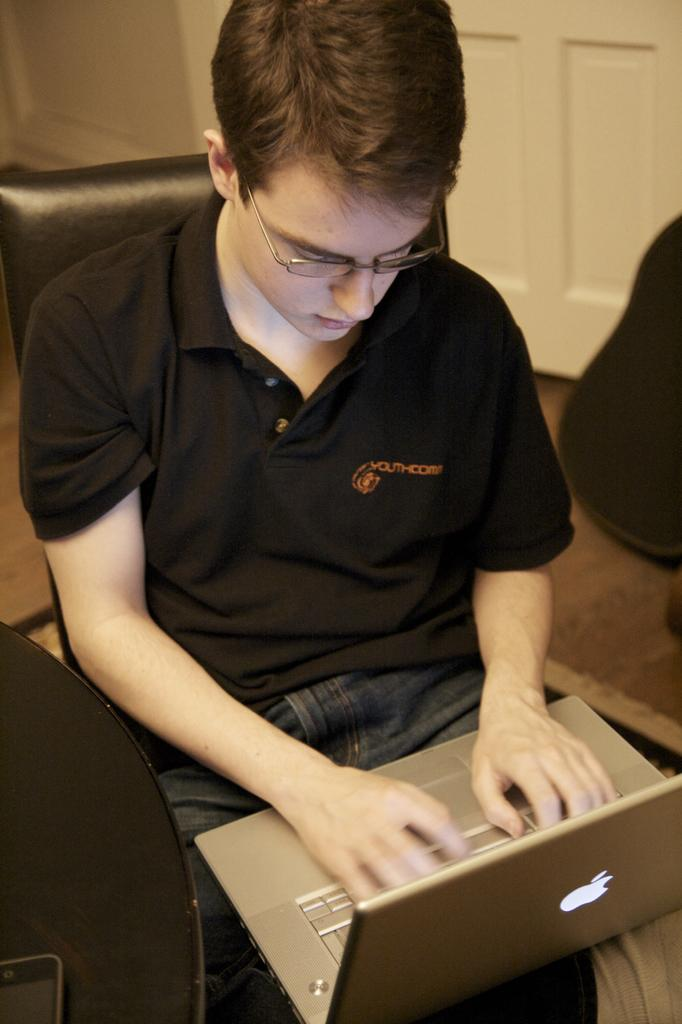Who is present in the image? There is a man in the image. What is the man doing in the image? The man is sitting on a chair and using a laptop. What can be seen in the background of the image? There is a door in the background of the image. What type of question is the man asking in the image? There is no indication in the image that the man is asking a question. 